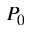<formula> <loc_0><loc_0><loc_500><loc_500>P _ { 0 }</formula> 